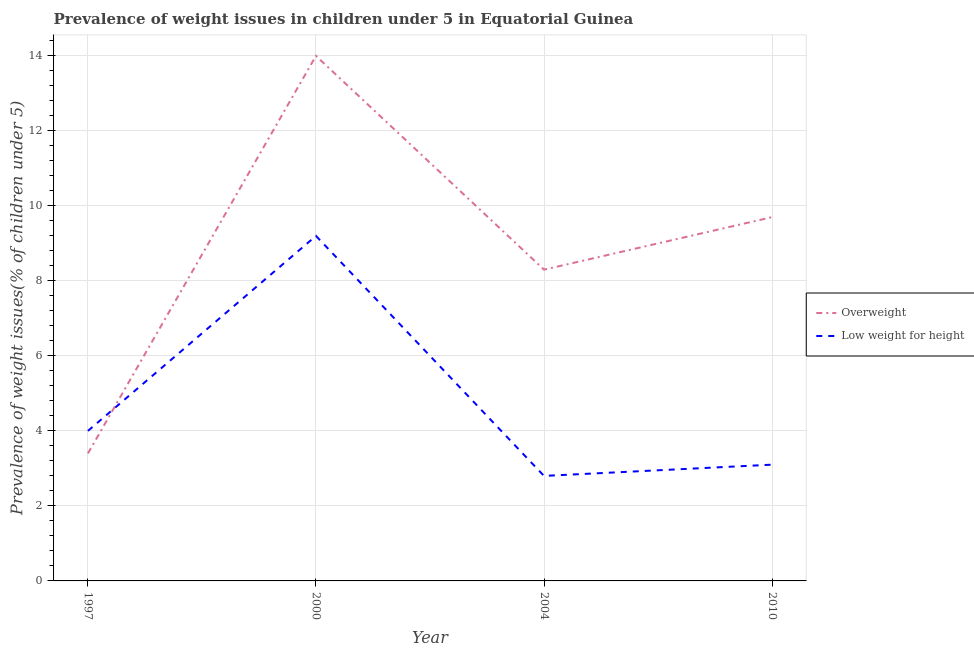How many different coloured lines are there?
Offer a terse response. 2. Does the line corresponding to percentage of overweight children intersect with the line corresponding to percentage of underweight children?
Provide a short and direct response. Yes. What is the percentage of overweight children in 2010?
Keep it short and to the point. 9.7. Across all years, what is the maximum percentage of overweight children?
Your answer should be compact. 14. Across all years, what is the minimum percentage of overweight children?
Offer a terse response. 3.4. In which year was the percentage of overweight children minimum?
Make the answer very short. 1997. What is the total percentage of underweight children in the graph?
Provide a succinct answer. 19.1. What is the difference between the percentage of overweight children in 1997 and that in 2010?
Your response must be concise. -6.3. What is the difference between the percentage of underweight children in 2004 and the percentage of overweight children in 1997?
Your answer should be very brief. -0.6. What is the average percentage of overweight children per year?
Ensure brevity in your answer.  8.85. In the year 2010, what is the difference between the percentage of underweight children and percentage of overweight children?
Ensure brevity in your answer.  -6.6. In how many years, is the percentage of overweight children greater than 5.2 %?
Give a very brief answer. 3. What is the ratio of the percentage of underweight children in 1997 to that in 2004?
Ensure brevity in your answer.  1.43. Is the percentage of underweight children in 1997 less than that in 2000?
Provide a short and direct response. Yes. Is the difference between the percentage of overweight children in 1997 and 2000 greater than the difference between the percentage of underweight children in 1997 and 2000?
Make the answer very short. No. What is the difference between the highest and the second highest percentage of overweight children?
Offer a very short reply. 4.3. What is the difference between the highest and the lowest percentage of underweight children?
Ensure brevity in your answer.  6.4. Is the percentage of underweight children strictly less than the percentage of overweight children over the years?
Give a very brief answer. No. How many lines are there?
Your answer should be very brief. 2. How many years are there in the graph?
Provide a succinct answer. 4. Are the values on the major ticks of Y-axis written in scientific E-notation?
Give a very brief answer. No. Does the graph contain grids?
Provide a succinct answer. Yes. Where does the legend appear in the graph?
Offer a very short reply. Center right. How many legend labels are there?
Provide a succinct answer. 2. What is the title of the graph?
Your answer should be compact. Prevalence of weight issues in children under 5 in Equatorial Guinea. What is the label or title of the X-axis?
Offer a terse response. Year. What is the label or title of the Y-axis?
Your response must be concise. Prevalence of weight issues(% of children under 5). What is the Prevalence of weight issues(% of children under 5) in Overweight in 1997?
Make the answer very short. 3.4. What is the Prevalence of weight issues(% of children under 5) in Low weight for height in 1997?
Give a very brief answer. 4. What is the Prevalence of weight issues(% of children under 5) of Overweight in 2000?
Your answer should be very brief. 14. What is the Prevalence of weight issues(% of children under 5) in Low weight for height in 2000?
Ensure brevity in your answer.  9.2. What is the Prevalence of weight issues(% of children under 5) of Overweight in 2004?
Your answer should be very brief. 8.3. What is the Prevalence of weight issues(% of children under 5) in Low weight for height in 2004?
Keep it short and to the point. 2.8. What is the Prevalence of weight issues(% of children under 5) of Overweight in 2010?
Your answer should be very brief. 9.7. What is the Prevalence of weight issues(% of children under 5) in Low weight for height in 2010?
Your response must be concise. 3.1. Across all years, what is the maximum Prevalence of weight issues(% of children under 5) in Overweight?
Offer a terse response. 14. Across all years, what is the maximum Prevalence of weight issues(% of children under 5) of Low weight for height?
Offer a very short reply. 9.2. Across all years, what is the minimum Prevalence of weight issues(% of children under 5) of Overweight?
Provide a succinct answer. 3.4. Across all years, what is the minimum Prevalence of weight issues(% of children under 5) in Low weight for height?
Offer a terse response. 2.8. What is the total Prevalence of weight issues(% of children under 5) of Overweight in the graph?
Provide a succinct answer. 35.4. What is the total Prevalence of weight issues(% of children under 5) in Low weight for height in the graph?
Provide a short and direct response. 19.1. What is the difference between the Prevalence of weight issues(% of children under 5) of Overweight in 1997 and that in 2000?
Ensure brevity in your answer.  -10.6. What is the difference between the Prevalence of weight issues(% of children under 5) of Low weight for height in 1997 and that in 2000?
Keep it short and to the point. -5.2. What is the difference between the Prevalence of weight issues(% of children under 5) of Overweight in 1997 and that in 2004?
Keep it short and to the point. -4.9. What is the difference between the Prevalence of weight issues(% of children under 5) of Overweight in 1997 and that in 2010?
Keep it short and to the point. -6.3. What is the difference between the Prevalence of weight issues(% of children under 5) in Low weight for height in 2004 and that in 2010?
Your response must be concise. -0.3. What is the difference between the Prevalence of weight issues(% of children under 5) in Overweight in 1997 and the Prevalence of weight issues(% of children under 5) in Low weight for height in 2000?
Your answer should be compact. -5.8. What is the difference between the Prevalence of weight issues(% of children under 5) in Overweight in 1997 and the Prevalence of weight issues(% of children under 5) in Low weight for height in 2010?
Ensure brevity in your answer.  0.3. What is the difference between the Prevalence of weight issues(% of children under 5) in Overweight in 2000 and the Prevalence of weight issues(% of children under 5) in Low weight for height in 2004?
Offer a terse response. 11.2. What is the average Prevalence of weight issues(% of children under 5) of Overweight per year?
Offer a very short reply. 8.85. What is the average Prevalence of weight issues(% of children under 5) of Low weight for height per year?
Provide a succinct answer. 4.78. In the year 1997, what is the difference between the Prevalence of weight issues(% of children under 5) of Overweight and Prevalence of weight issues(% of children under 5) of Low weight for height?
Offer a very short reply. -0.6. In the year 2000, what is the difference between the Prevalence of weight issues(% of children under 5) in Overweight and Prevalence of weight issues(% of children under 5) in Low weight for height?
Provide a short and direct response. 4.8. In the year 2010, what is the difference between the Prevalence of weight issues(% of children under 5) of Overweight and Prevalence of weight issues(% of children under 5) of Low weight for height?
Your answer should be compact. 6.6. What is the ratio of the Prevalence of weight issues(% of children under 5) in Overweight in 1997 to that in 2000?
Offer a very short reply. 0.24. What is the ratio of the Prevalence of weight issues(% of children under 5) of Low weight for height in 1997 to that in 2000?
Give a very brief answer. 0.43. What is the ratio of the Prevalence of weight issues(% of children under 5) of Overweight in 1997 to that in 2004?
Keep it short and to the point. 0.41. What is the ratio of the Prevalence of weight issues(% of children under 5) in Low weight for height in 1997 to that in 2004?
Give a very brief answer. 1.43. What is the ratio of the Prevalence of weight issues(% of children under 5) in Overweight in 1997 to that in 2010?
Provide a succinct answer. 0.35. What is the ratio of the Prevalence of weight issues(% of children under 5) in Low weight for height in 1997 to that in 2010?
Keep it short and to the point. 1.29. What is the ratio of the Prevalence of weight issues(% of children under 5) of Overweight in 2000 to that in 2004?
Provide a succinct answer. 1.69. What is the ratio of the Prevalence of weight issues(% of children under 5) of Low weight for height in 2000 to that in 2004?
Your response must be concise. 3.29. What is the ratio of the Prevalence of weight issues(% of children under 5) of Overweight in 2000 to that in 2010?
Provide a succinct answer. 1.44. What is the ratio of the Prevalence of weight issues(% of children under 5) in Low weight for height in 2000 to that in 2010?
Offer a terse response. 2.97. What is the ratio of the Prevalence of weight issues(% of children under 5) of Overweight in 2004 to that in 2010?
Make the answer very short. 0.86. What is the ratio of the Prevalence of weight issues(% of children under 5) of Low weight for height in 2004 to that in 2010?
Your answer should be very brief. 0.9. What is the difference between the highest and the lowest Prevalence of weight issues(% of children under 5) in Overweight?
Give a very brief answer. 10.6. What is the difference between the highest and the lowest Prevalence of weight issues(% of children under 5) of Low weight for height?
Keep it short and to the point. 6.4. 